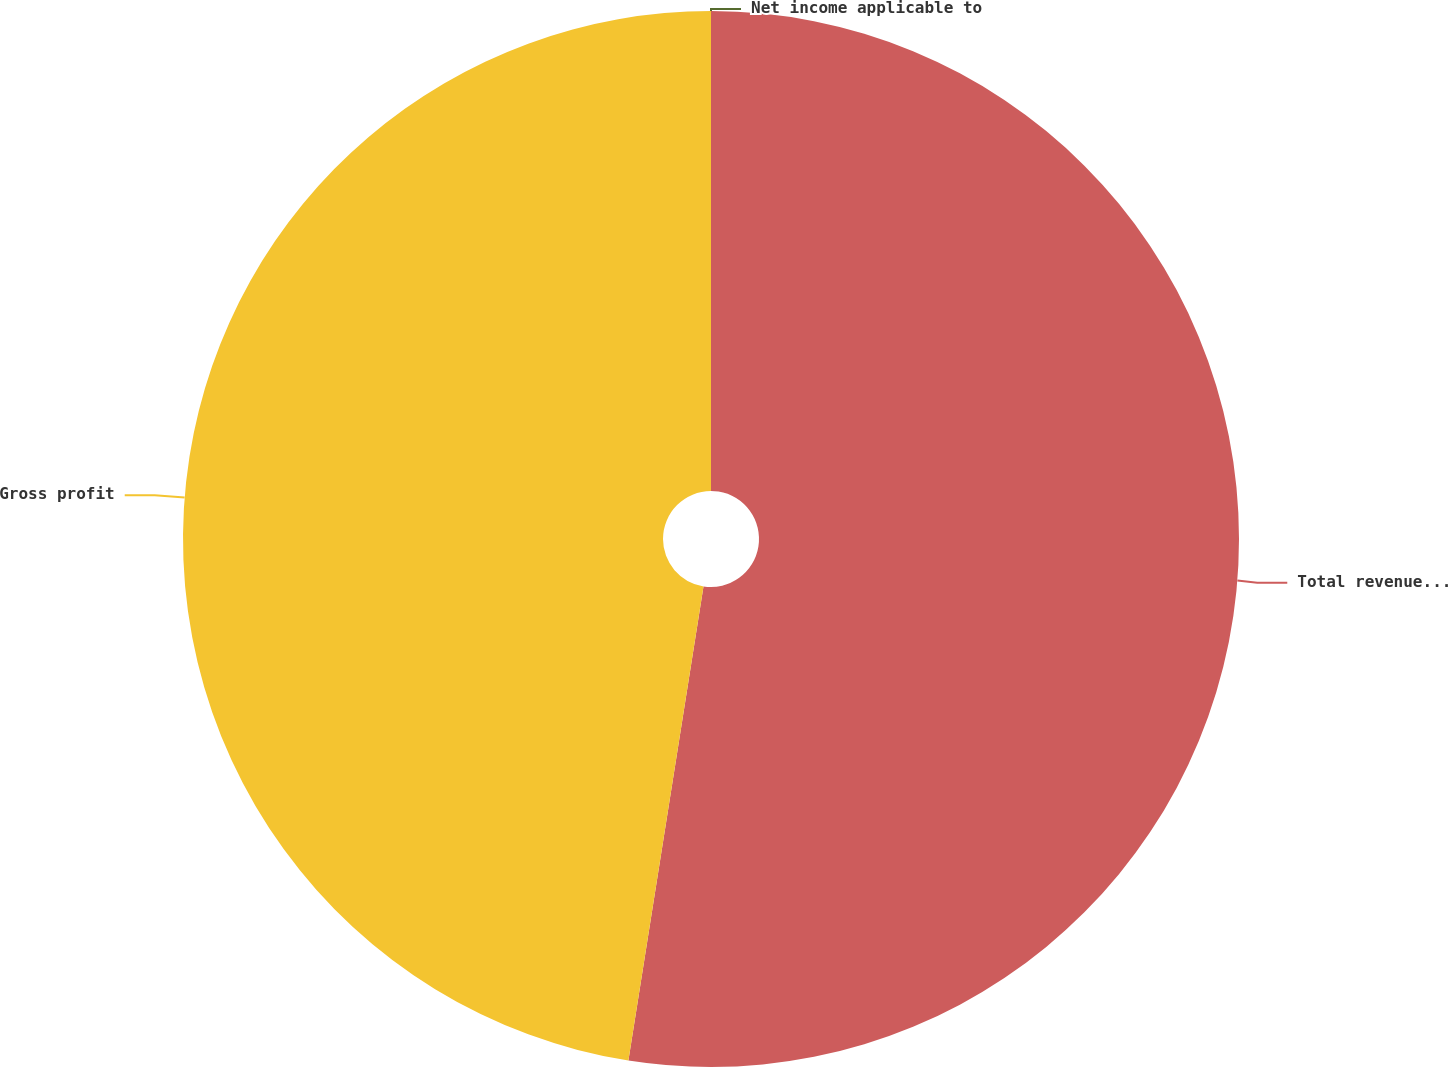<chart> <loc_0><loc_0><loc_500><loc_500><pie_chart><fcel>Total revenues (1)<fcel>Gross profit<fcel>Net income applicable to<nl><fcel>52.5%<fcel>47.5%<fcel>0.0%<nl></chart> 